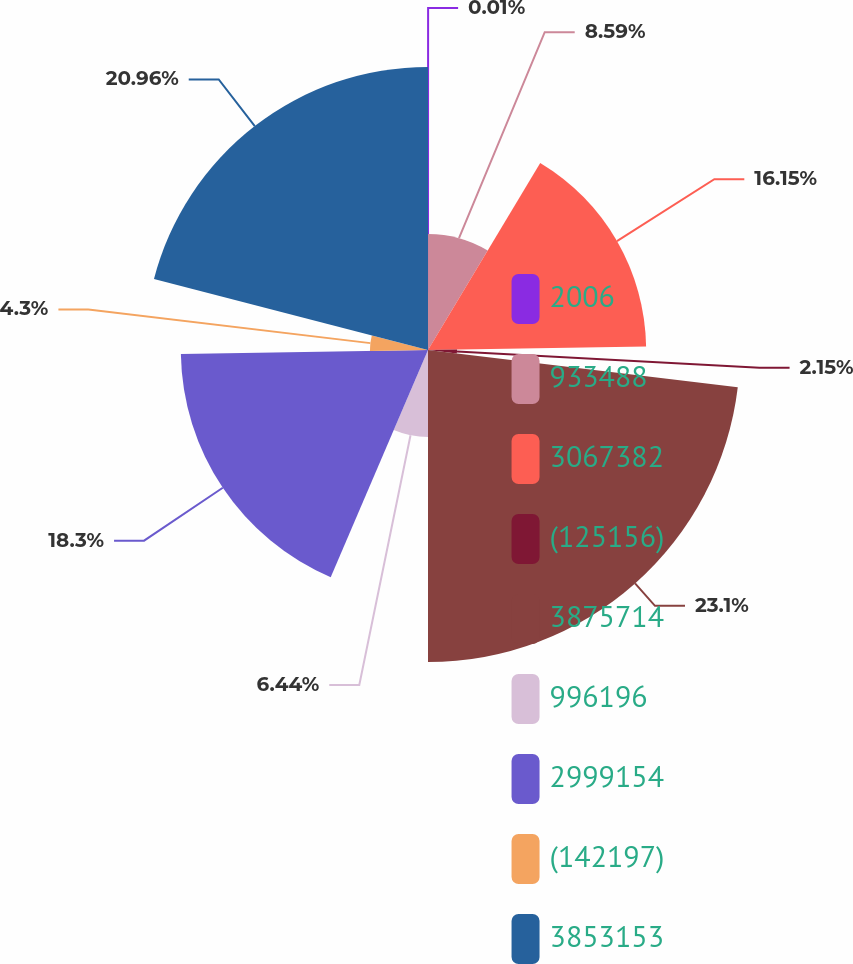Convert chart to OTSL. <chart><loc_0><loc_0><loc_500><loc_500><pie_chart><fcel>2006<fcel>933488<fcel>3067382<fcel>(125156)<fcel>3875714<fcel>996196<fcel>2999154<fcel>(142197)<fcel>3853153<nl><fcel>0.01%<fcel>8.59%<fcel>16.15%<fcel>2.15%<fcel>23.1%<fcel>6.44%<fcel>18.3%<fcel>4.3%<fcel>20.96%<nl></chart> 